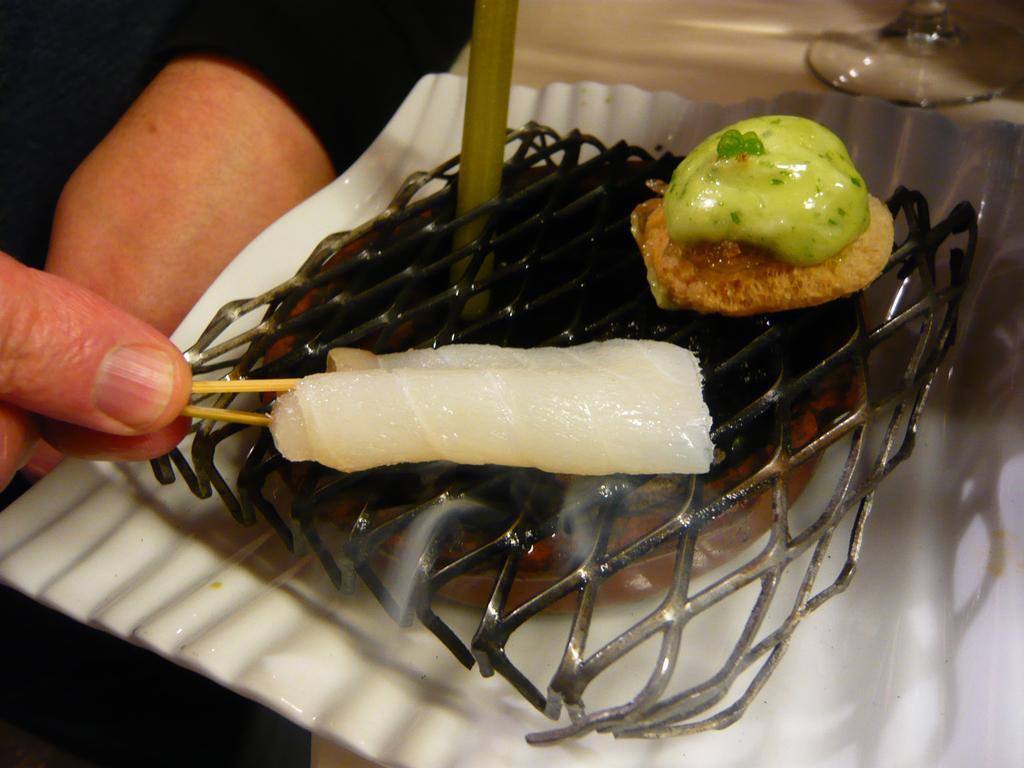Could you give a brief overview of what you see in this image? In this picture I can observe some food placed on the grill. On the left side I can observe a human hand. In the top right side I can observe a glass on the table. 